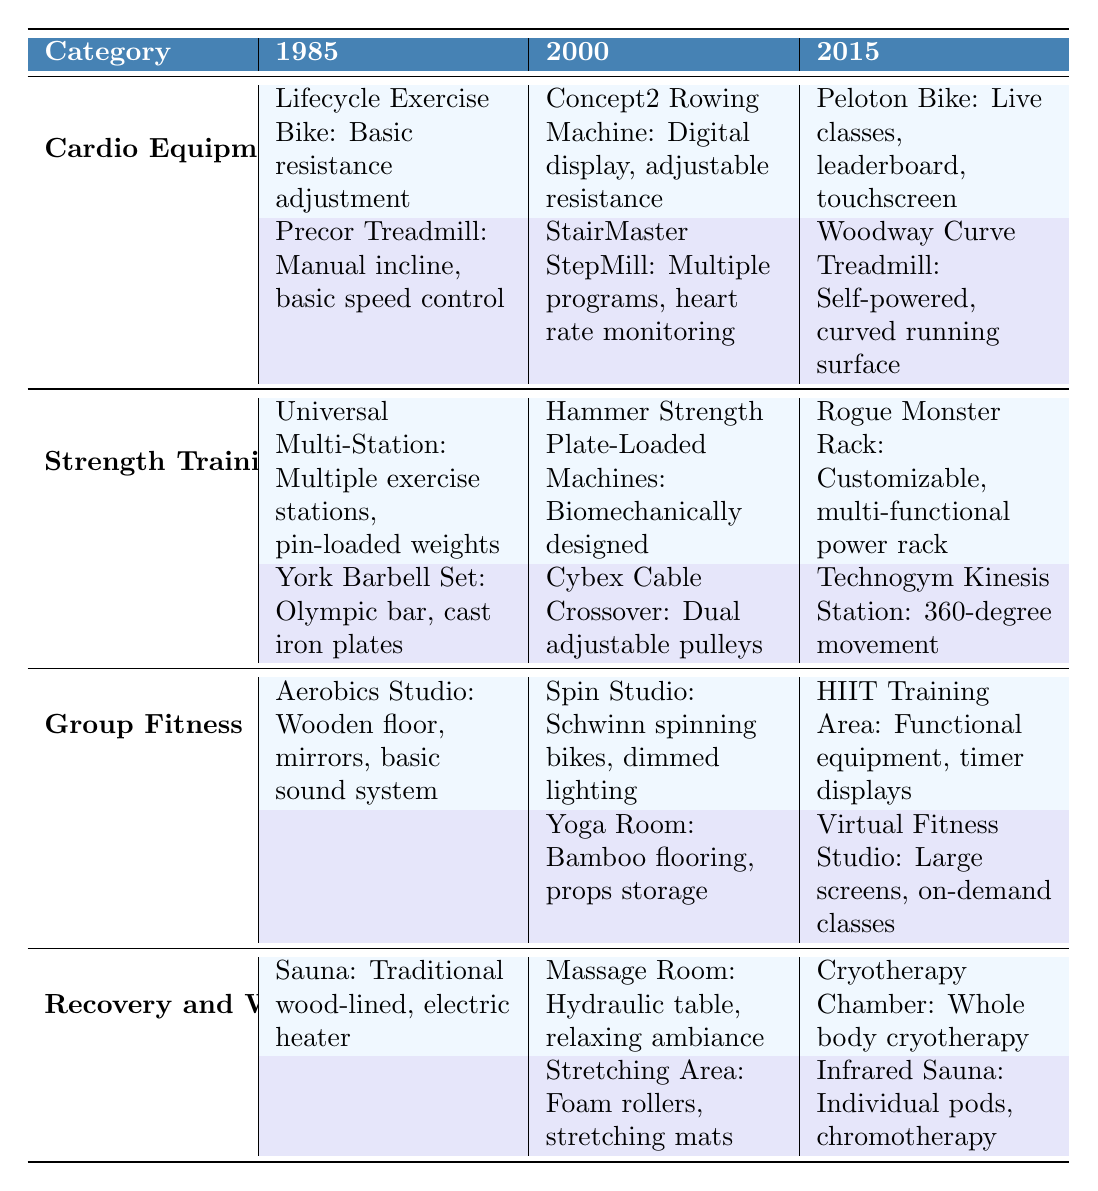What cardio equipment was introduced in 2000? In the "Cardio Equipment" section under the year 2000, we can see the two items listed: "Concept2 Rowing Machine" and "StairMaster StepMill."
Answer: Concept2 Rowing Machine, StairMaster StepMill What features does the Peloton Bike have? The Peloton Bike is listed under 2015 in the "Cardio Equipment" category, and its features are "Live classes, leaderboard, touchscreen."
Answer: Live classes, leaderboard, touchscreen Is there a stretching area in the gym in 2015? In the "Recovery and Wellness" section for the year 2015, the presence of the "Stretching Area" is confirmed, which includes "Foam rollers, stretching mats."
Answer: Yes Which type of equipment was introduced first in the strength training category? In the "Strength Training" section under the year 1985, the first equipment listed is the "Universal Multi-Station." This indicates it was introduced first among listed items.
Answer: Universal Multi-Station How many different types of group fitness areas were updated from 2000 to 2015? From the "Group Fitness" section, in 2000, there were three types (Spin Studio, Yoga Room) and in 2015, there were also three types (HIIT Training Area, Virtual Fitness Studio). The updates in types show a general continuity without clear replacement. Therefore, no new types were introduced, but there are new features highlighting a diversification in offerings.
Answer: 0 Which brand introduced a massage room in the year 2000? Looking at the "Recovery and Wellness" for the year 2000, the "Massage Room" is listed and has the feature of "Hydraulic table, relaxing ambiance." The brand is not specified, indicating it may be general equipment available at that time.
Answer: Not specified What features differentiate the HIIT Training Area from the Aerobics Studio? In the "Group Fitness" category, the "HIIT Training Area," introduced in 2015, contains "Functional equipment, timer displays," whereas the "Aerobics Studio," existing since 1985, has "Wooden floor, mirrors, basic sound system." The differentiation lies in the equipment type and the additional feature of timer displays in the HIIT area.
Answer: Functional equipment, timer displays vs. Wooden floor, mirrors Which category has the most equipment entries for the year 2000? Analyzing the table, both the "Cardio Equipment" and "Strength Training" categories have two entries each for the year 2000; "Group Fitness" supports two entries, and "Recovery and Wellness" also has two. Thus, the four categories are tied based on this count.
Answer: All categories are tied (4) What has evolved in the cardio equipment from 1985 to 2015? Comparing the entries from 1985 to 2015, we notice advancements from basic functionality to high-tech features like live classes and touchscreens with the Peloton Bike. There's a clear evolution in terms of user engagement and technology integration.
Answer: Significant technological advancements Is the Infrared Sauna a new feature in 2015 compared to 1985? At 1985, only a traditional Sauna was listed under "Recovery and Wellness," while 2015 introduced an Infrared Sauna, indicating it is indeed a new feature added to the gym offerings.
Answer: Yes, it's a new feature 